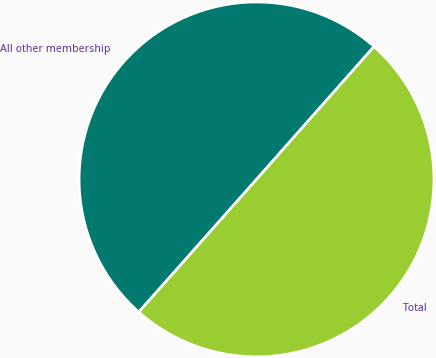<chart> <loc_0><loc_0><loc_500><loc_500><pie_chart><fcel>All other membership<fcel>Total<nl><fcel>49.98%<fcel>50.02%<nl></chart> 